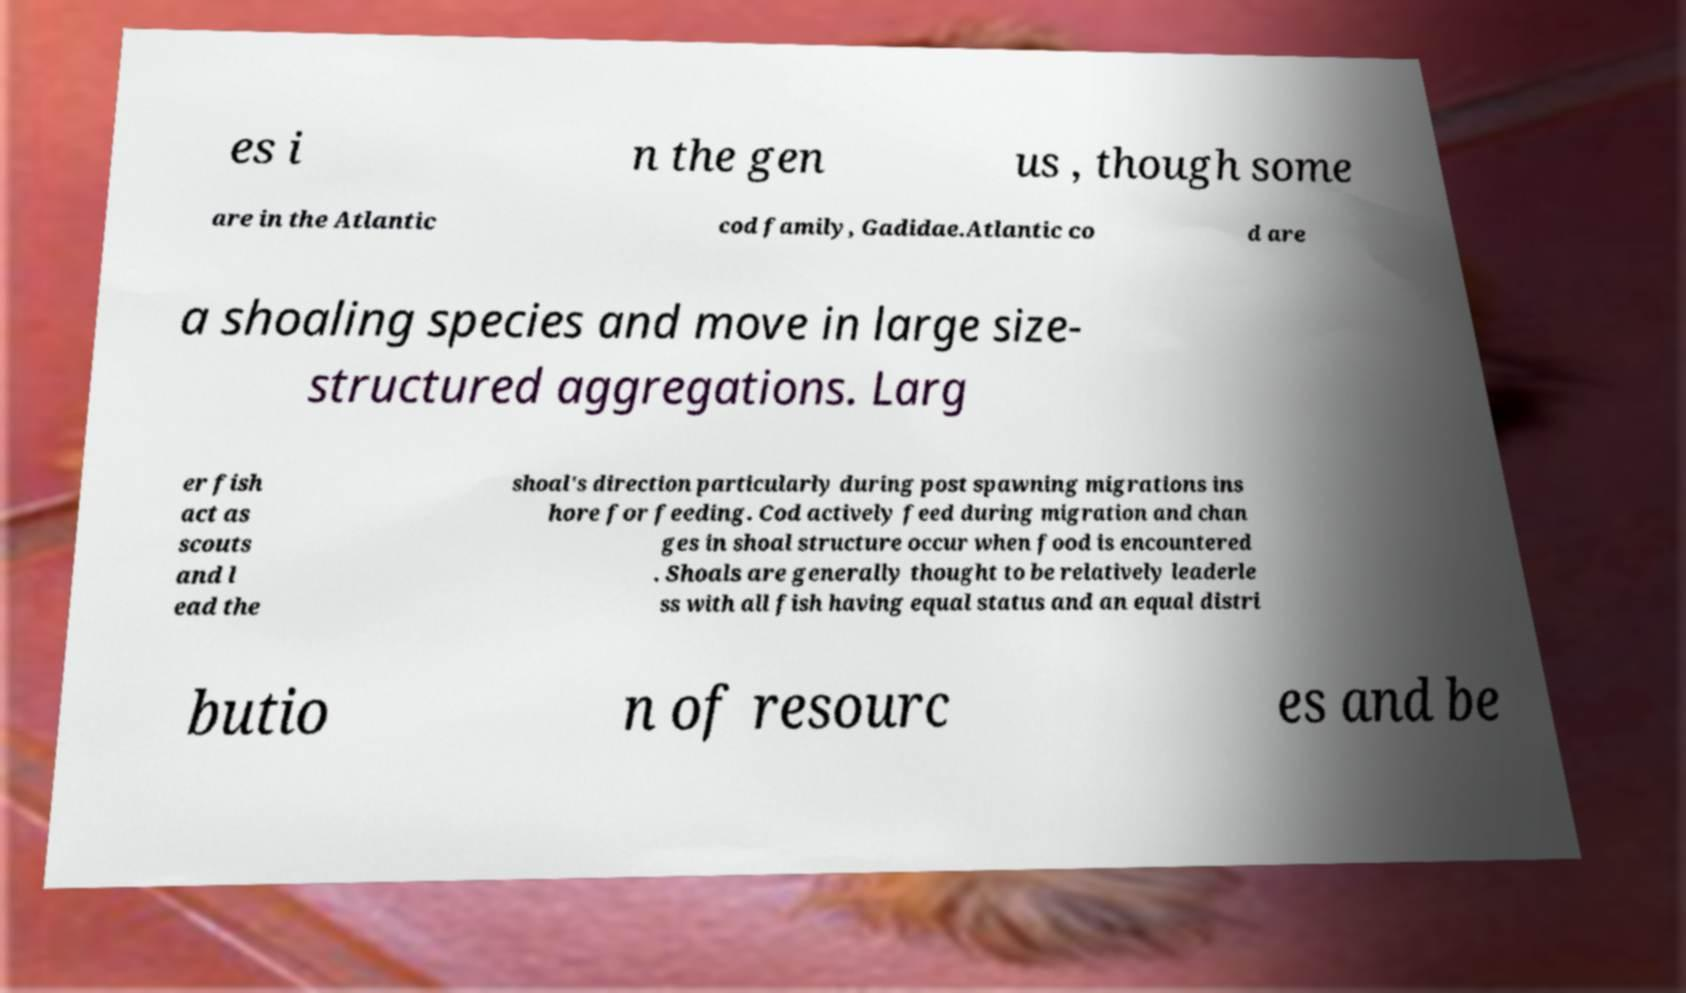I need the written content from this picture converted into text. Can you do that? es i n the gen us , though some are in the Atlantic cod family, Gadidae.Atlantic co d are a shoaling species and move in large size- structured aggregations. Larg er fish act as scouts and l ead the shoal's direction particularly during post spawning migrations ins hore for feeding. Cod actively feed during migration and chan ges in shoal structure occur when food is encountered . Shoals are generally thought to be relatively leaderle ss with all fish having equal status and an equal distri butio n of resourc es and be 